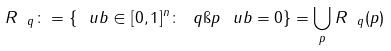<formula> <loc_0><loc_0><loc_500><loc_500>R _ { \ q } \colon = \{ \ u b \in [ 0 , 1 ] ^ { n } \colon \| \ q \i p \ u b \| = 0 \} = \bigcup _ { p } R _ { \ q } ( p )</formula> 